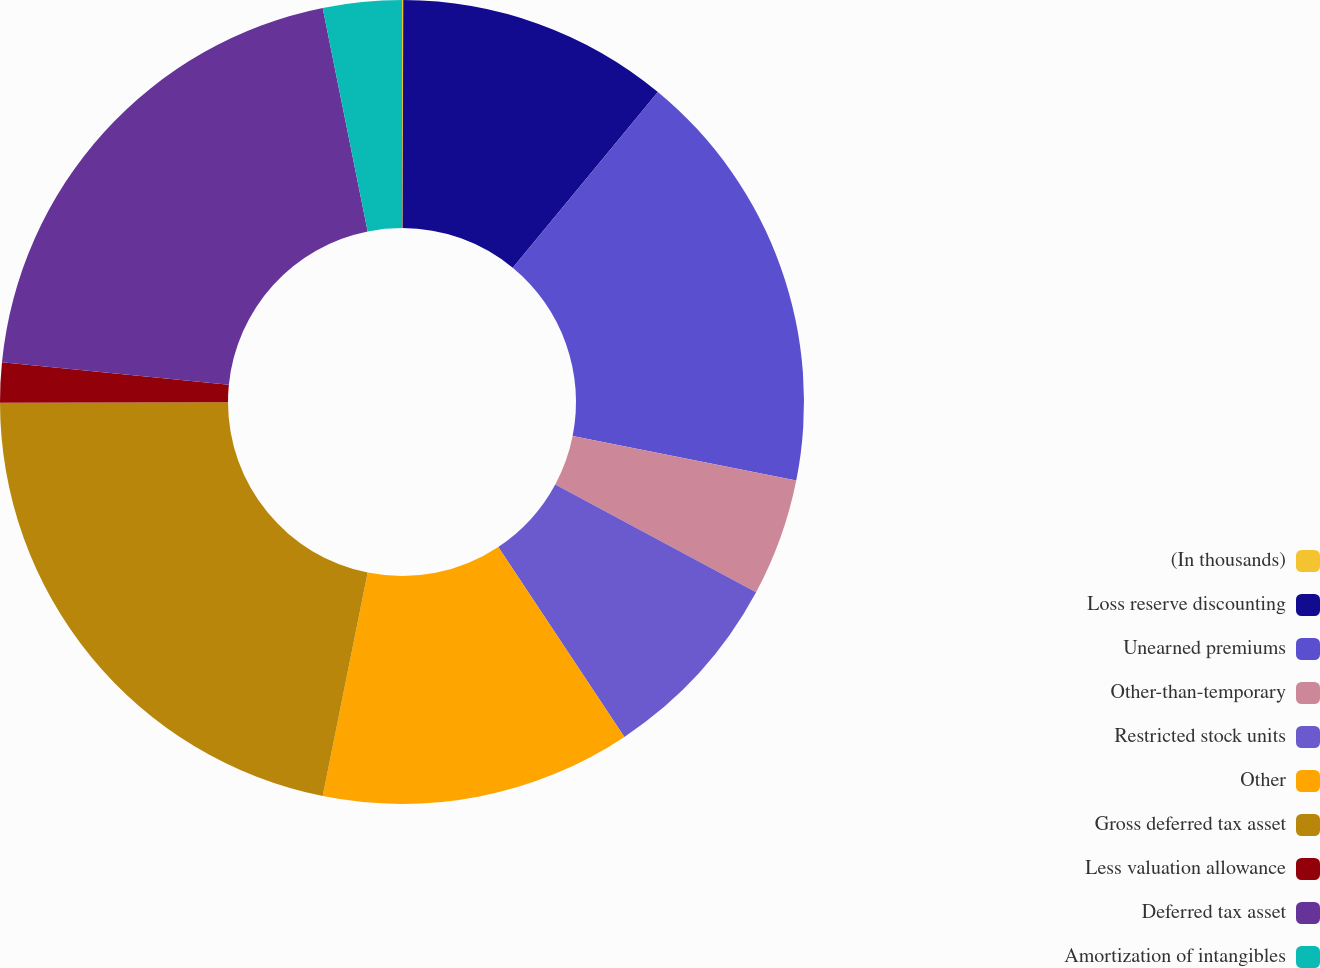Convert chart to OTSL. <chart><loc_0><loc_0><loc_500><loc_500><pie_chart><fcel>(In thousands)<fcel>Loss reserve discounting<fcel>Unearned premiums<fcel>Other-than-temporary<fcel>Restricted stock units<fcel>Other<fcel>Gross deferred tax asset<fcel>Less valuation allowance<fcel>Deferred tax asset<fcel>Amortization of intangibles<nl><fcel>0.05%<fcel>10.93%<fcel>17.15%<fcel>4.72%<fcel>7.82%<fcel>12.49%<fcel>21.81%<fcel>1.61%<fcel>20.26%<fcel>3.16%<nl></chart> 